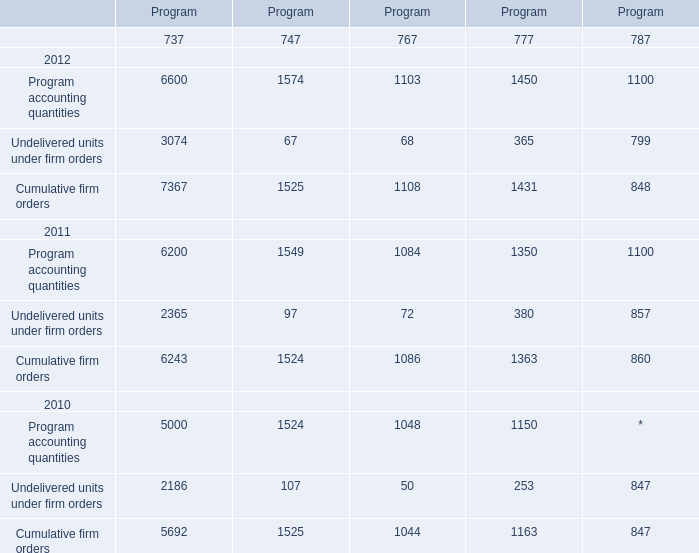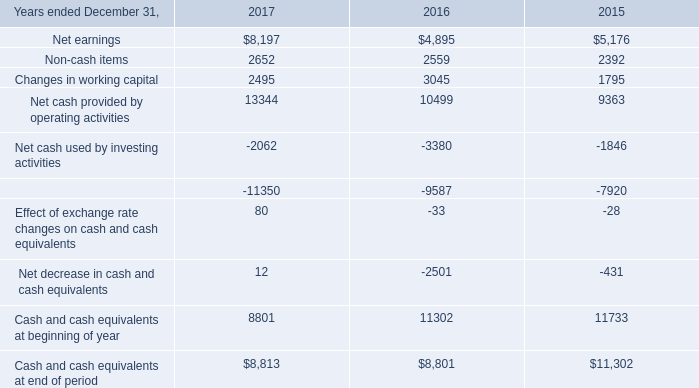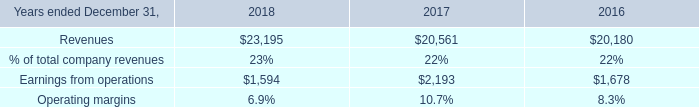What is the total amount of Net cash used by investing activities of 2015, Cumulative firm orders 2011 of Program.1, and Cumulative firm orders 2012 of Program.2 ? 
Computations: ((1846.0 + 1524.0) + 1108.0)
Answer: 4478.0. 